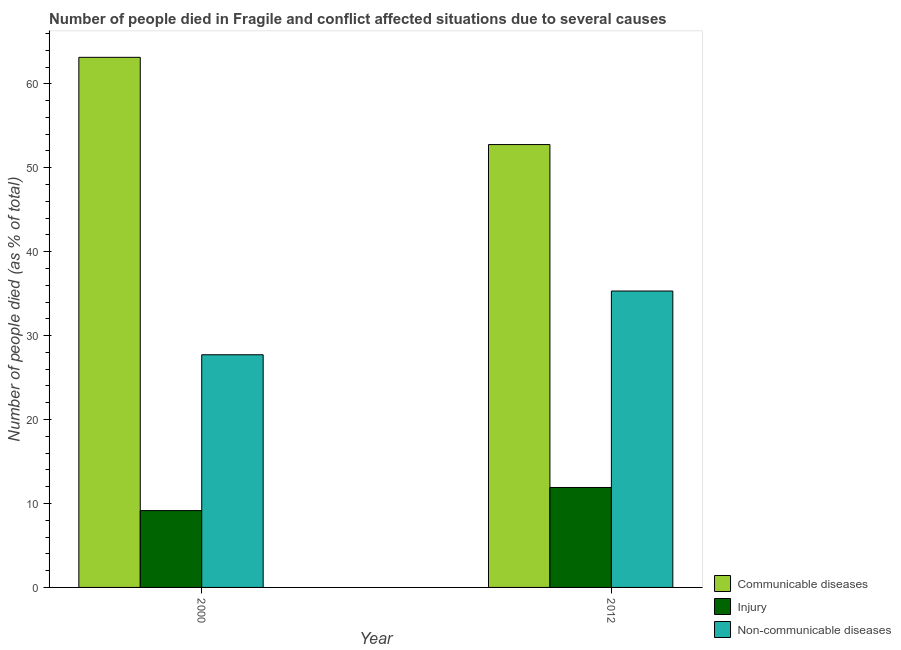How many different coloured bars are there?
Make the answer very short. 3. Are the number of bars per tick equal to the number of legend labels?
Provide a succinct answer. Yes. How many bars are there on the 1st tick from the right?
Make the answer very short. 3. What is the number of people who died of communicable diseases in 2012?
Ensure brevity in your answer.  52.76. Across all years, what is the maximum number of people who dies of non-communicable diseases?
Your response must be concise. 35.31. Across all years, what is the minimum number of people who dies of non-communicable diseases?
Offer a very short reply. 27.72. In which year was the number of people who died of communicable diseases minimum?
Ensure brevity in your answer.  2012. What is the total number of people who died of communicable diseases in the graph?
Offer a terse response. 115.91. What is the difference between the number of people who died of communicable diseases in 2000 and that in 2012?
Ensure brevity in your answer.  10.39. What is the difference between the number of people who dies of non-communicable diseases in 2000 and the number of people who died of communicable diseases in 2012?
Ensure brevity in your answer.  -7.59. What is the average number of people who died of communicable diseases per year?
Provide a short and direct response. 57.96. In the year 2000, what is the difference between the number of people who dies of non-communicable diseases and number of people who died of communicable diseases?
Offer a very short reply. 0. What is the ratio of the number of people who dies of non-communicable diseases in 2000 to that in 2012?
Your answer should be compact. 0.78. What does the 1st bar from the left in 2000 represents?
Ensure brevity in your answer.  Communicable diseases. What does the 2nd bar from the right in 2000 represents?
Offer a very short reply. Injury. Is it the case that in every year, the sum of the number of people who died of communicable diseases and number of people who died of injury is greater than the number of people who dies of non-communicable diseases?
Ensure brevity in your answer.  Yes. How many bars are there?
Offer a very short reply. 6. Are all the bars in the graph horizontal?
Provide a succinct answer. No. What is the difference between two consecutive major ticks on the Y-axis?
Give a very brief answer. 10. Where does the legend appear in the graph?
Offer a very short reply. Bottom right. How are the legend labels stacked?
Keep it short and to the point. Vertical. What is the title of the graph?
Your answer should be compact. Number of people died in Fragile and conflict affected situations due to several causes. Does "Labor Market" appear as one of the legend labels in the graph?
Your response must be concise. No. What is the label or title of the Y-axis?
Ensure brevity in your answer.  Number of people died (as % of total). What is the Number of people died (as % of total) in Communicable diseases in 2000?
Keep it short and to the point. 63.15. What is the Number of people died (as % of total) of Injury in 2000?
Give a very brief answer. 9.15. What is the Number of people died (as % of total) in Non-communicable diseases in 2000?
Ensure brevity in your answer.  27.72. What is the Number of people died (as % of total) in Communicable diseases in 2012?
Offer a terse response. 52.76. What is the Number of people died (as % of total) of Injury in 2012?
Your answer should be very brief. 11.91. What is the Number of people died (as % of total) of Non-communicable diseases in 2012?
Provide a short and direct response. 35.31. Across all years, what is the maximum Number of people died (as % of total) in Communicable diseases?
Offer a terse response. 63.15. Across all years, what is the maximum Number of people died (as % of total) in Injury?
Offer a very short reply. 11.91. Across all years, what is the maximum Number of people died (as % of total) of Non-communicable diseases?
Provide a succinct answer. 35.31. Across all years, what is the minimum Number of people died (as % of total) in Communicable diseases?
Keep it short and to the point. 52.76. Across all years, what is the minimum Number of people died (as % of total) in Injury?
Give a very brief answer. 9.15. Across all years, what is the minimum Number of people died (as % of total) of Non-communicable diseases?
Offer a terse response. 27.72. What is the total Number of people died (as % of total) of Communicable diseases in the graph?
Your answer should be very brief. 115.91. What is the total Number of people died (as % of total) of Injury in the graph?
Your response must be concise. 21.06. What is the total Number of people died (as % of total) in Non-communicable diseases in the graph?
Offer a terse response. 63.03. What is the difference between the Number of people died (as % of total) in Communicable diseases in 2000 and that in 2012?
Keep it short and to the point. 10.39. What is the difference between the Number of people died (as % of total) in Injury in 2000 and that in 2012?
Provide a succinct answer. -2.75. What is the difference between the Number of people died (as % of total) in Non-communicable diseases in 2000 and that in 2012?
Offer a very short reply. -7.59. What is the difference between the Number of people died (as % of total) of Communicable diseases in 2000 and the Number of people died (as % of total) of Injury in 2012?
Provide a succinct answer. 51.25. What is the difference between the Number of people died (as % of total) of Communicable diseases in 2000 and the Number of people died (as % of total) of Non-communicable diseases in 2012?
Make the answer very short. 27.84. What is the difference between the Number of people died (as % of total) of Injury in 2000 and the Number of people died (as % of total) of Non-communicable diseases in 2012?
Your response must be concise. -26.16. What is the average Number of people died (as % of total) of Communicable diseases per year?
Your answer should be compact. 57.96. What is the average Number of people died (as % of total) in Injury per year?
Offer a terse response. 10.53. What is the average Number of people died (as % of total) in Non-communicable diseases per year?
Your answer should be compact. 31.52. In the year 2000, what is the difference between the Number of people died (as % of total) of Communicable diseases and Number of people died (as % of total) of Injury?
Your answer should be very brief. 54. In the year 2000, what is the difference between the Number of people died (as % of total) of Communicable diseases and Number of people died (as % of total) of Non-communicable diseases?
Give a very brief answer. 35.43. In the year 2000, what is the difference between the Number of people died (as % of total) in Injury and Number of people died (as % of total) in Non-communicable diseases?
Offer a very short reply. -18.57. In the year 2012, what is the difference between the Number of people died (as % of total) of Communicable diseases and Number of people died (as % of total) of Injury?
Ensure brevity in your answer.  40.85. In the year 2012, what is the difference between the Number of people died (as % of total) of Communicable diseases and Number of people died (as % of total) of Non-communicable diseases?
Make the answer very short. 17.45. In the year 2012, what is the difference between the Number of people died (as % of total) in Injury and Number of people died (as % of total) in Non-communicable diseases?
Your response must be concise. -23.41. What is the ratio of the Number of people died (as % of total) of Communicable diseases in 2000 to that in 2012?
Provide a succinct answer. 1.2. What is the ratio of the Number of people died (as % of total) of Injury in 2000 to that in 2012?
Your answer should be compact. 0.77. What is the ratio of the Number of people died (as % of total) in Non-communicable diseases in 2000 to that in 2012?
Provide a short and direct response. 0.79. What is the difference between the highest and the second highest Number of people died (as % of total) in Communicable diseases?
Your answer should be compact. 10.39. What is the difference between the highest and the second highest Number of people died (as % of total) in Injury?
Ensure brevity in your answer.  2.75. What is the difference between the highest and the second highest Number of people died (as % of total) in Non-communicable diseases?
Ensure brevity in your answer.  7.59. What is the difference between the highest and the lowest Number of people died (as % of total) of Communicable diseases?
Make the answer very short. 10.39. What is the difference between the highest and the lowest Number of people died (as % of total) in Injury?
Provide a short and direct response. 2.75. What is the difference between the highest and the lowest Number of people died (as % of total) of Non-communicable diseases?
Your response must be concise. 7.59. 